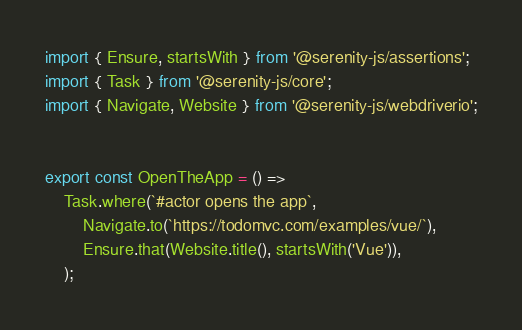Convert code to text. <code><loc_0><loc_0><loc_500><loc_500><_TypeScript_>import { Ensure, startsWith } from '@serenity-js/assertions';
import { Task } from '@serenity-js/core';
import { Navigate, Website } from '@serenity-js/webdriverio';


export const OpenTheApp = () =>
    Task.where(`#actor opens the app`,
        Navigate.to(`https://todomvc.com/examples/vue/`),
        Ensure.that(Website.title(), startsWith('Vue')),
    );
</code> 